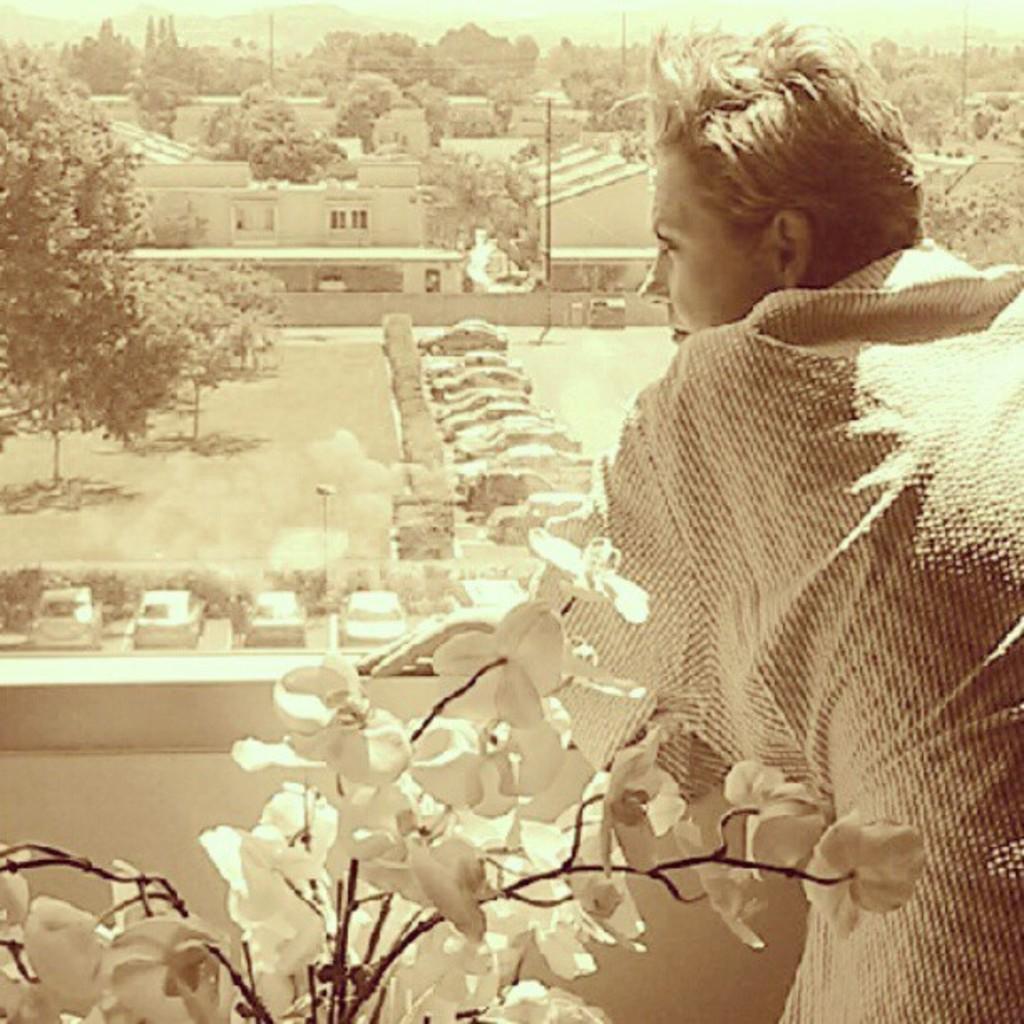In one or two sentences, can you explain what this image depicts? On the right side of the image we can see a person standing. In the center there is a plant. In the background we can see cars, trees, buildings, poles and sky. 